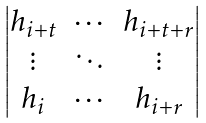Convert formula to latex. <formula><loc_0><loc_0><loc_500><loc_500>\begin{vmatrix} h _ { i + t } & \cdots & h _ { i + t + r } \\ \vdots & \ddots & \vdots \\ h _ { i } & \cdots & h _ { i + r } \end{vmatrix}</formula> 